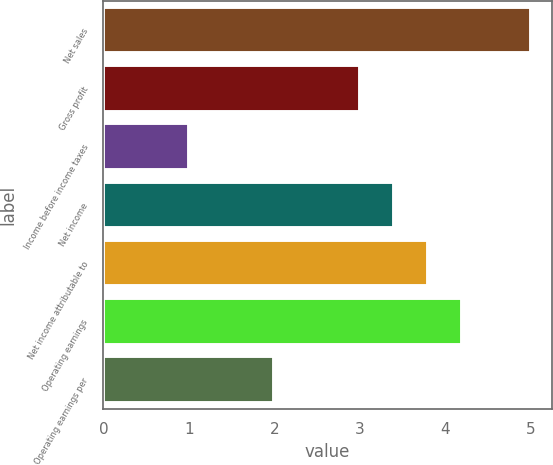Convert chart to OTSL. <chart><loc_0><loc_0><loc_500><loc_500><bar_chart><fcel>Net sales<fcel>Gross profit<fcel>Income before income taxes<fcel>Net income<fcel>Net income attributable to<fcel>Operating earnings<fcel>Operating earnings per<nl><fcel>5<fcel>3<fcel>1<fcel>3.4<fcel>3.8<fcel>4.2<fcel>2<nl></chart> 